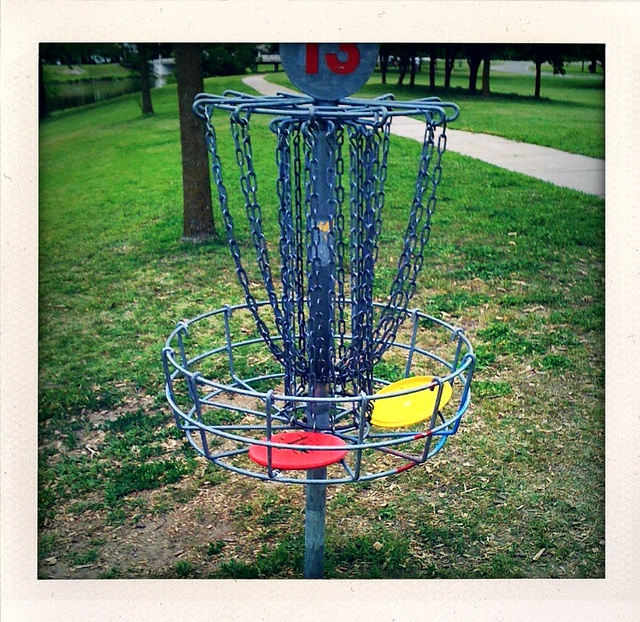Describe the objects in this image and their specific colors. I can see a frisbee in lightgray, yellow, salmon, and red tones in this image. 